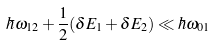<formula> <loc_0><loc_0><loc_500><loc_500>\hbar { \omega } _ { 1 2 } + \frac { 1 } { 2 } ( \delta E _ { 1 } + \delta E _ { 2 } ) \ll \hbar { \omega } _ { 0 1 }</formula> 